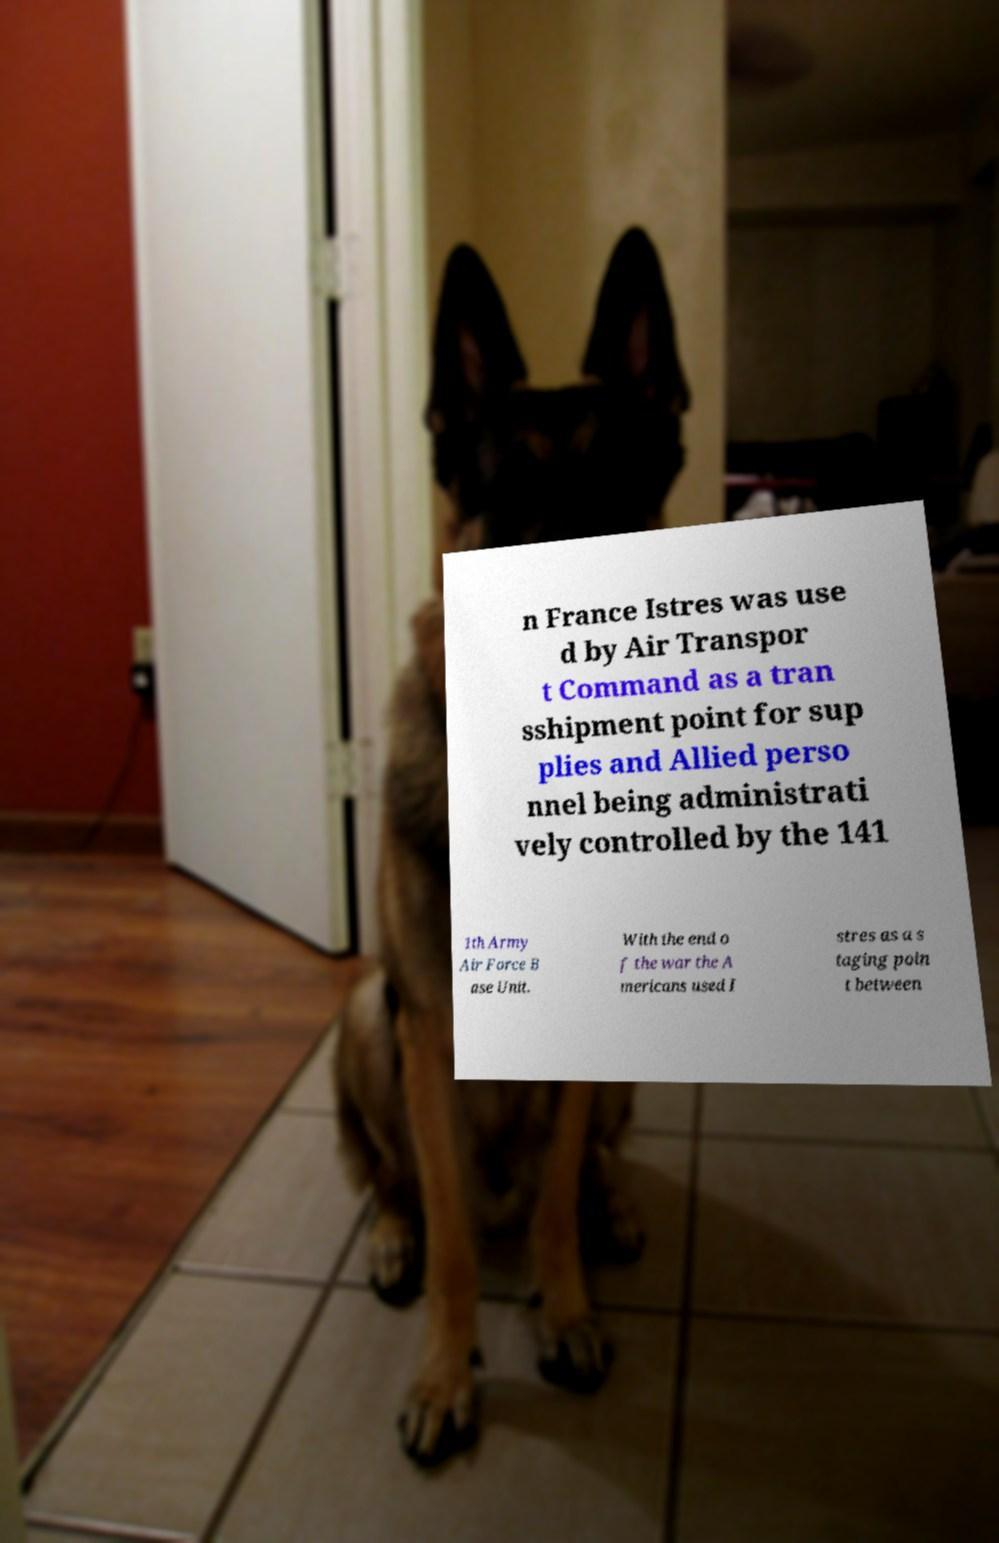For documentation purposes, I need the text within this image transcribed. Could you provide that? n France Istres was use d by Air Transpor t Command as a tran sshipment point for sup plies and Allied perso nnel being administrati vely controlled by the 141 1th Army Air Force B ase Unit. With the end o f the war the A mericans used I stres as a s taging poin t between 